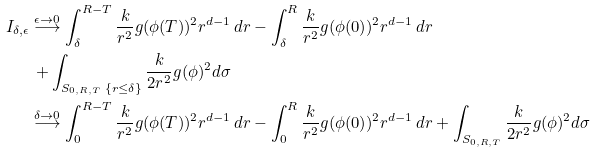<formula> <loc_0><loc_0><loc_500><loc_500>I _ { \delta , \epsilon } & \overset { \epsilon \rightarrow 0 } { \longrightarrow } \int _ { \delta } ^ { R - T } \frac { k } { r ^ { 2 } } g ( \phi ( T ) ) ^ { 2 } r ^ { d - 1 } \, d r - \int _ { \delta } ^ { R } \frac { k } { r ^ { 2 } } g ( \phi ( 0 ) ) ^ { 2 } r ^ { d - 1 } \, d r \\ & \, + \int _ { S _ { 0 , R , T } \ \{ r \leq \delta \} } \frac { k } { 2 r ^ { 2 } } g ( \phi ) ^ { 2 } d \sigma \\ & \overset { \delta \rightarrow 0 } { \longrightarrow } \int _ { 0 } ^ { R - T } \frac { k } { r ^ { 2 } } g ( \phi ( T ) ) ^ { 2 } r ^ { d - 1 } \, d r - \int _ { 0 } ^ { R } \frac { k } { r ^ { 2 } } g ( \phi ( 0 ) ) ^ { 2 } r ^ { d - 1 } \, d r + \int _ { S _ { 0 , R , T } } \frac { k } { 2 r ^ { 2 } } g ( \phi ) ^ { 2 } d \sigma \\</formula> 